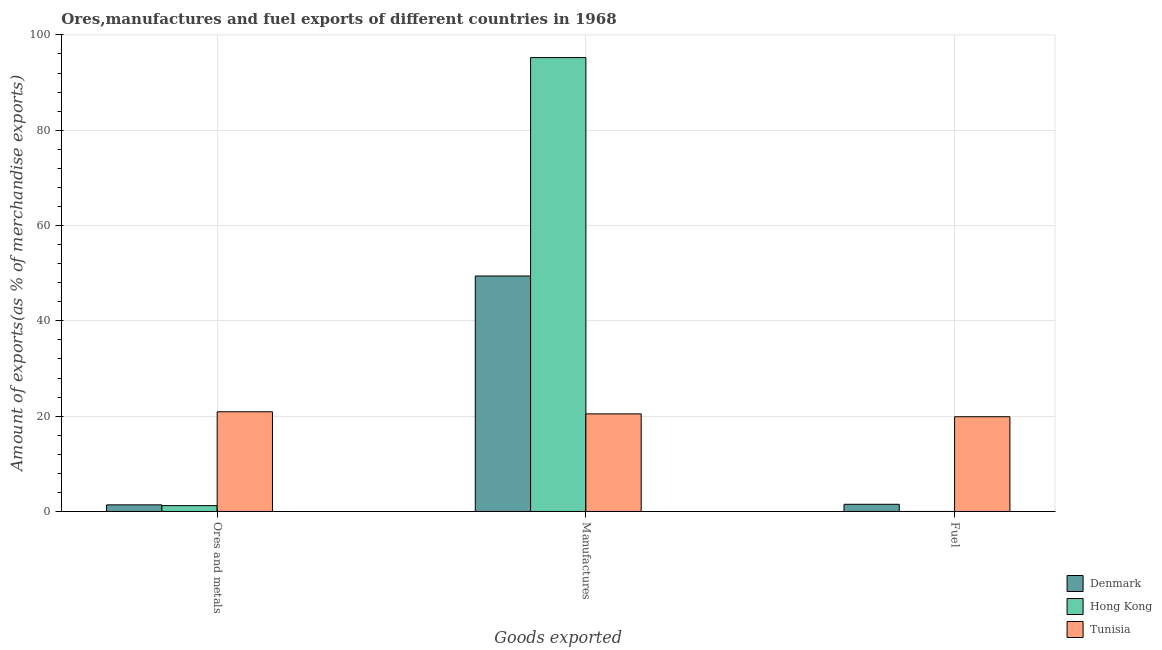How many groups of bars are there?
Your answer should be very brief. 3. Are the number of bars on each tick of the X-axis equal?
Your response must be concise. Yes. How many bars are there on the 2nd tick from the left?
Offer a very short reply. 3. How many bars are there on the 2nd tick from the right?
Provide a succinct answer. 3. What is the label of the 3rd group of bars from the left?
Your answer should be compact. Fuel. What is the percentage of manufactures exports in Tunisia?
Your answer should be very brief. 20.48. Across all countries, what is the maximum percentage of manufactures exports?
Provide a short and direct response. 95.25. Across all countries, what is the minimum percentage of ores and metals exports?
Give a very brief answer. 1.23. In which country was the percentage of manufactures exports maximum?
Offer a very short reply. Hong Kong. In which country was the percentage of manufactures exports minimum?
Offer a very short reply. Tunisia. What is the total percentage of fuel exports in the graph?
Offer a terse response. 21.4. What is the difference between the percentage of manufactures exports in Tunisia and that in Hong Kong?
Offer a very short reply. -74.77. What is the difference between the percentage of ores and metals exports in Denmark and the percentage of manufactures exports in Tunisia?
Your answer should be very brief. -19.09. What is the average percentage of manufactures exports per country?
Your answer should be very brief. 55.05. What is the difference between the percentage of ores and metals exports and percentage of manufactures exports in Hong Kong?
Your answer should be compact. -94.02. In how many countries, is the percentage of ores and metals exports greater than 48 %?
Your answer should be compact. 0. What is the ratio of the percentage of fuel exports in Hong Kong to that in Tunisia?
Offer a very short reply. 1.8551151160085775e-6. Is the percentage of fuel exports in Hong Kong less than that in Denmark?
Keep it short and to the point. Yes. Is the difference between the percentage of ores and metals exports in Denmark and Tunisia greater than the difference between the percentage of fuel exports in Denmark and Tunisia?
Offer a very short reply. No. What is the difference between the highest and the second highest percentage of ores and metals exports?
Your answer should be very brief. 19.53. What is the difference between the highest and the lowest percentage of fuel exports?
Give a very brief answer. 19.88. Is the sum of the percentage of fuel exports in Denmark and Hong Kong greater than the maximum percentage of manufactures exports across all countries?
Your answer should be very brief. No. What does the 2nd bar from the right in Fuel represents?
Provide a short and direct response. Hong Kong. How many bars are there?
Your response must be concise. 9. Are all the bars in the graph horizontal?
Your answer should be compact. No. How many countries are there in the graph?
Provide a succinct answer. 3. How are the legend labels stacked?
Provide a succinct answer. Vertical. What is the title of the graph?
Your answer should be very brief. Ores,manufactures and fuel exports of different countries in 1968. What is the label or title of the X-axis?
Your response must be concise. Goods exported. What is the label or title of the Y-axis?
Keep it short and to the point. Amount of exports(as % of merchandise exports). What is the Amount of exports(as % of merchandise exports) in Denmark in Ores and metals?
Keep it short and to the point. 1.39. What is the Amount of exports(as % of merchandise exports) of Hong Kong in Ores and metals?
Offer a very short reply. 1.23. What is the Amount of exports(as % of merchandise exports) in Tunisia in Ores and metals?
Offer a terse response. 20.92. What is the Amount of exports(as % of merchandise exports) of Denmark in Manufactures?
Your response must be concise. 49.41. What is the Amount of exports(as % of merchandise exports) in Hong Kong in Manufactures?
Make the answer very short. 95.25. What is the Amount of exports(as % of merchandise exports) in Tunisia in Manufactures?
Your response must be concise. 20.48. What is the Amount of exports(as % of merchandise exports) of Denmark in Fuel?
Your answer should be compact. 1.51. What is the Amount of exports(as % of merchandise exports) in Hong Kong in Fuel?
Give a very brief answer. 3.68883836952435e-5. What is the Amount of exports(as % of merchandise exports) of Tunisia in Fuel?
Your answer should be compact. 19.88. Across all Goods exported, what is the maximum Amount of exports(as % of merchandise exports) of Denmark?
Your response must be concise. 49.41. Across all Goods exported, what is the maximum Amount of exports(as % of merchandise exports) in Hong Kong?
Offer a terse response. 95.25. Across all Goods exported, what is the maximum Amount of exports(as % of merchandise exports) in Tunisia?
Keep it short and to the point. 20.92. Across all Goods exported, what is the minimum Amount of exports(as % of merchandise exports) of Denmark?
Keep it short and to the point. 1.39. Across all Goods exported, what is the minimum Amount of exports(as % of merchandise exports) in Hong Kong?
Your answer should be compact. 3.68883836952435e-5. Across all Goods exported, what is the minimum Amount of exports(as % of merchandise exports) of Tunisia?
Make the answer very short. 19.88. What is the total Amount of exports(as % of merchandise exports) of Denmark in the graph?
Your response must be concise. 52.31. What is the total Amount of exports(as % of merchandise exports) in Hong Kong in the graph?
Keep it short and to the point. 96.48. What is the total Amount of exports(as % of merchandise exports) in Tunisia in the graph?
Ensure brevity in your answer.  61.29. What is the difference between the Amount of exports(as % of merchandise exports) in Denmark in Ores and metals and that in Manufactures?
Give a very brief answer. -48.02. What is the difference between the Amount of exports(as % of merchandise exports) of Hong Kong in Ores and metals and that in Manufactures?
Offer a terse response. -94.02. What is the difference between the Amount of exports(as % of merchandise exports) of Tunisia in Ores and metals and that in Manufactures?
Your answer should be very brief. 0.44. What is the difference between the Amount of exports(as % of merchandise exports) in Denmark in Ores and metals and that in Fuel?
Your answer should be compact. -0.12. What is the difference between the Amount of exports(as % of merchandise exports) of Hong Kong in Ores and metals and that in Fuel?
Your response must be concise. 1.23. What is the difference between the Amount of exports(as % of merchandise exports) of Tunisia in Ores and metals and that in Fuel?
Provide a short and direct response. 1.04. What is the difference between the Amount of exports(as % of merchandise exports) in Denmark in Manufactures and that in Fuel?
Give a very brief answer. 47.9. What is the difference between the Amount of exports(as % of merchandise exports) of Hong Kong in Manufactures and that in Fuel?
Your response must be concise. 95.25. What is the difference between the Amount of exports(as % of merchandise exports) of Tunisia in Manufactures and that in Fuel?
Provide a succinct answer. 0.6. What is the difference between the Amount of exports(as % of merchandise exports) of Denmark in Ores and metals and the Amount of exports(as % of merchandise exports) of Hong Kong in Manufactures?
Your answer should be very brief. -93.86. What is the difference between the Amount of exports(as % of merchandise exports) of Denmark in Ores and metals and the Amount of exports(as % of merchandise exports) of Tunisia in Manufactures?
Ensure brevity in your answer.  -19.09. What is the difference between the Amount of exports(as % of merchandise exports) of Hong Kong in Ores and metals and the Amount of exports(as % of merchandise exports) of Tunisia in Manufactures?
Make the answer very short. -19.25. What is the difference between the Amount of exports(as % of merchandise exports) in Denmark in Ores and metals and the Amount of exports(as % of merchandise exports) in Hong Kong in Fuel?
Make the answer very short. 1.39. What is the difference between the Amount of exports(as % of merchandise exports) in Denmark in Ores and metals and the Amount of exports(as % of merchandise exports) in Tunisia in Fuel?
Offer a terse response. -18.49. What is the difference between the Amount of exports(as % of merchandise exports) of Hong Kong in Ores and metals and the Amount of exports(as % of merchandise exports) of Tunisia in Fuel?
Keep it short and to the point. -18.66. What is the difference between the Amount of exports(as % of merchandise exports) in Denmark in Manufactures and the Amount of exports(as % of merchandise exports) in Hong Kong in Fuel?
Offer a very short reply. 49.41. What is the difference between the Amount of exports(as % of merchandise exports) in Denmark in Manufactures and the Amount of exports(as % of merchandise exports) in Tunisia in Fuel?
Offer a very short reply. 29.53. What is the difference between the Amount of exports(as % of merchandise exports) in Hong Kong in Manufactures and the Amount of exports(as % of merchandise exports) in Tunisia in Fuel?
Your response must be concise. 75.36. What is the average Amount of exports(as % of merchandise exports) of Denmark per Goods exported?
Keep it short and to the point. 17.44. What is the average Amount of exports(as % of merchandise exports) of Hong Kong per Goods exported?
Ensure brevity in your answer.  32.16. What is the average Amount of exports(as % of merchandise exports) in Tunisia per Goods exported?
Ensure brevity in your answer.  20.43. What is the difference between the Amount of exports(as % of merchandise exports) in Denmark and Amount of exports(as % of merchandise exports) in Hong Kong in Ores and metals?
Provide a short and direct response. 0.16. What is the difference between the Amount of exports(as % of merchandise exports) of Denmark and Amount of exports(as % of merchandise exports) of Tunisia in Ores and metals?
Your response must be concise. -19.53. What is the difference between the Amount of exports(as % of merchandise exports) of Hong Kong and Amount of exports(as % of merchandise exports) of Tunisia in Ores and metals?
Keep it short and to the point. -19.69. What is the difference between the Amount of exports(as % of merchandise exports) of Denmark and Amount of exports(as % of merchandise exports) of Hong Kong in Manufactures?
Offer a very short reply. -45.84. What is the difference between the Amount of exports(as % of merchandise exports) of Denmark and Amount of exports(as % of merchandise exports) of Tunisia in Manufactures?
Your answer should be very brief. 28.93. What is the difference between the Amount of exports(as % of merchandise exports) in Hong Kong and Amount of exports(as % of merchandise exports) in Tunisia in Manufactures?
Your answer should be very brief. 74.77. What is the difference between the Amount of exports(as % of merchandise exports) in Denmark and Amount of exports(as % of merchandise exports) in Hong Kong in Fuel?
Provide a succinct answer. 1.51. What is the difference between the Amount of exports(as % of merchandise exports) in Denmark and Amount of exports(as % of merchandise exports) in Tunisia in Fuel?
Provide a short and direct response. -18.37. What is the difference between the Amount of exports(as % of merchandise exports) in Hong Kong and Amount of exports(as % of merchandise exports) in Tunisia in Fuel?
Give a very brief answer. -19.88. What is the ratio of the Amount of exports(as % of merchandise exports) in Denmark in Ores and metals to that in Manufactures?
Offer a terse response. 0.03. What is the ratio of the Amount of exports(as % of merchandise exports) of Hong Kong in Ores and metals to that in Manufactures?
Ensure brevity in your answer.  0.01. What is the ratio of the Amount of exports(as % of merchandise exports) of Tunisia in Ores and metals to that in Manufactures?
Your answer should be very brief. 1.02. What is the ratio of the Amount of exports(as % of merchandise exports) in Denmark in Ores and metals to that in Fuel?
Your response must be concise. 0.92. What is the ratio of the Amount of exports(as % of merchandise exports) in Hong Kong in Ores and metals to that in Fuel?
Provide a succinct answer. 3.33e+04. What is the ratio of the Amount of exports(as % of merchandise exports) of Tunisia in Ores and metals to that in Fuel?
Offer a terse response. 1.05. What is the ratio of the Amount of exports(as % of merchandise exports) in Denmark in Manufactures to that in Fuel?
Ensure brevity in your answer.  32.71. What is the ratio of the Amount of exports(as % of merchandise exports) of Hong Kong in Manufactures to that in Fuel?
Your answer should be compact. 2.58e+06. What is the ratio of the Amount of exports(as % of merchandise exports) of Tunisia in Manufactures to that in Fuel?
Your answer should be compact. 1.03. What is the difference between the highest and the second highest Amount of exports(as % of merchandise exports) in Denmark?
Offer a very short reply. 47.9. What is the difference between the highest and the second highest Amount of exports(as % of merchandise exports) of Hong Kong?
Offer a very short reply. 94.02. What is the difference between the highest and the second highest Amount of exports(as % of merchandise exports) of Tunisia?
Keep it short and to the point. 0.44. What is the difference between the highest and the lowest Amount of exports(as % of merchandise exports) in Denmark?
Your response must be concise. 48.02. What is the difference between the highest and the lowest Amount of exports(as % of merchandise exports) in Hong Kong?
Your answer should be very brief. 95.25. What is the difference between the highest and the lowest Amount of exports(as % of merchandise exports) in Tunisia?
Your answer should be compact. 1.04. 